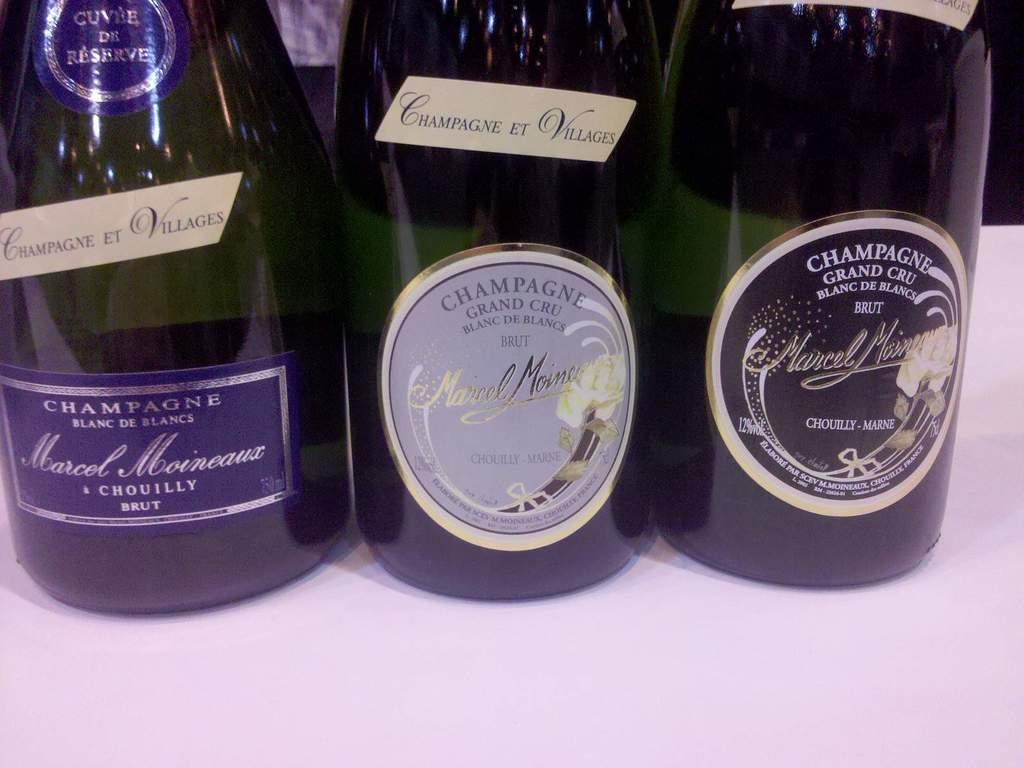<image>
Provide a brief description of the given image. three bottles of brut champagne bottled by marcel moineaux 